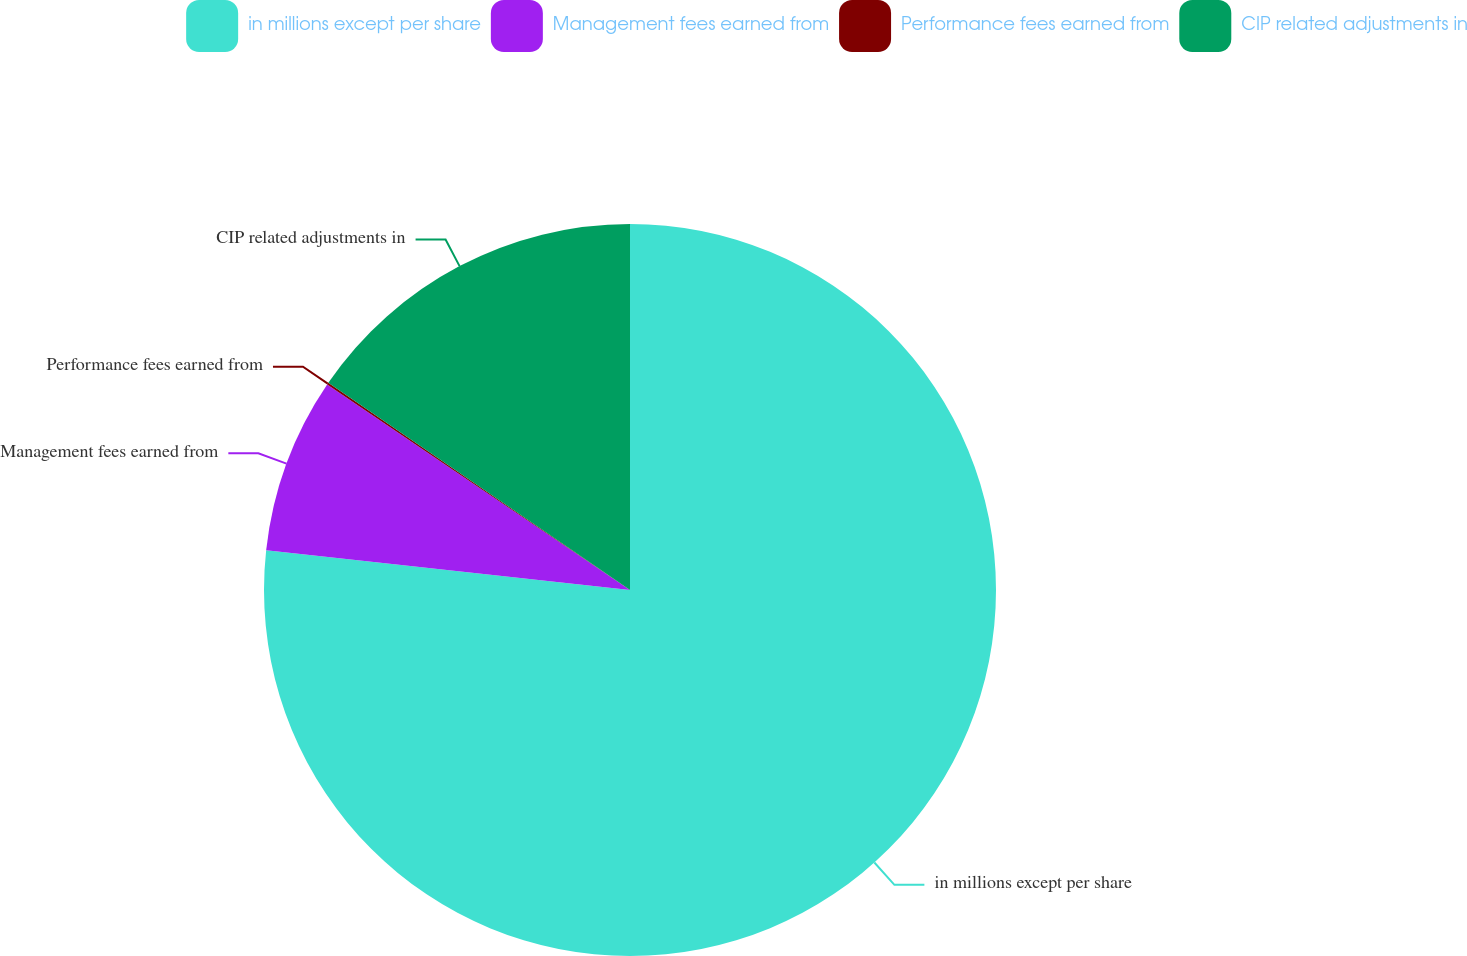Convert chart to OTSL. <chart><loc_0><loc_0><loc_500><loc_500><pie_chart><fcel>in millions except per share<fcel>Management fees earned from<fcel>Performance fees earned from<fcel>CIP related adjustments in<nl><fcel>76.73%<fcel>7.76%<fcel>0.09%<fcel>15.42%<nl></chart> 